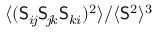<formula> <loc_0><loc_0><loc_500><loc_500>{ \langle ( S _ { i \, j } S _ { \, j \, k } S _ { k i } ) ^ { 2 } \rangle } / { \langle S ^ { 2 } \rangle } ^ { 3 }</formula> 